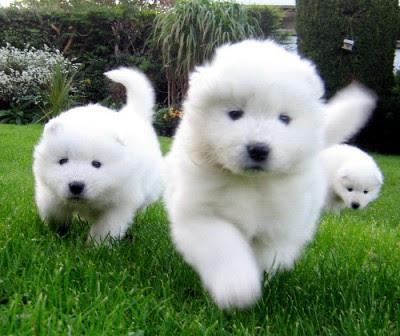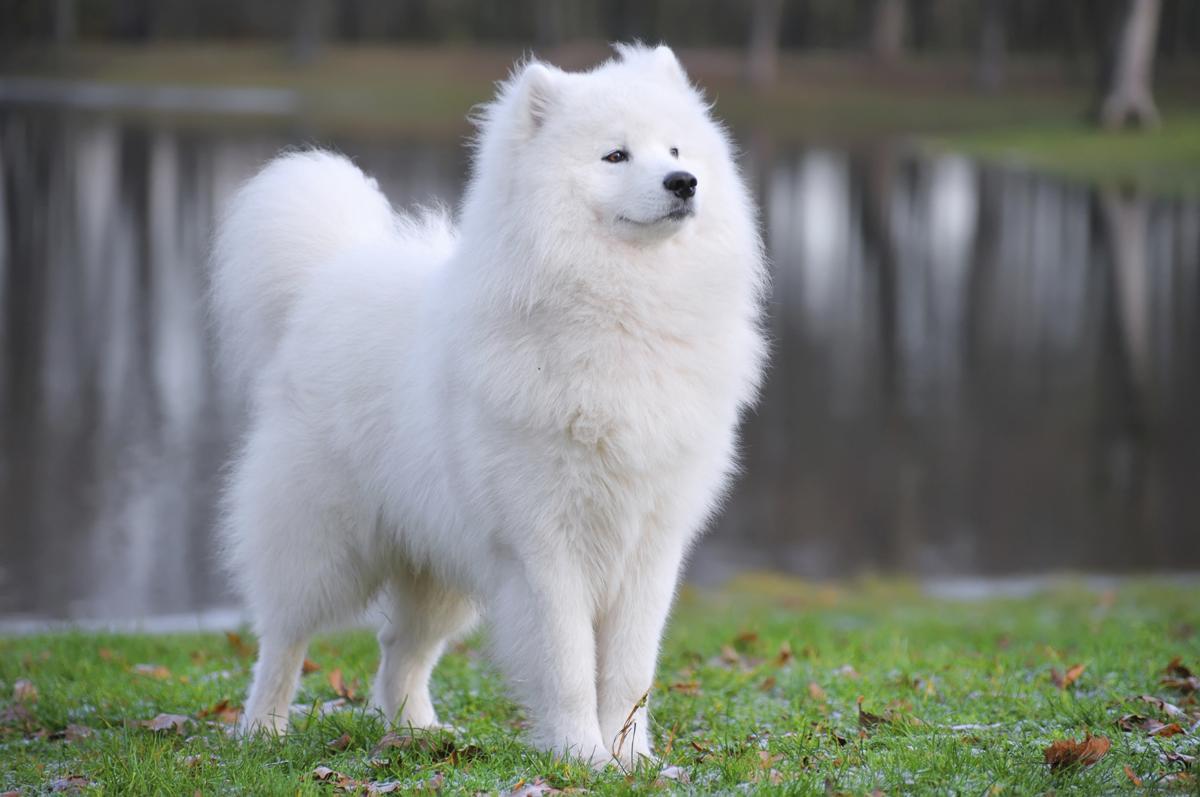The first image is the image on the left, the second image is the image on the right. Analyze the images presented: Is the assertion "Combined, the images contain exactly four animals." valid? Answer yes or no. Yes. 